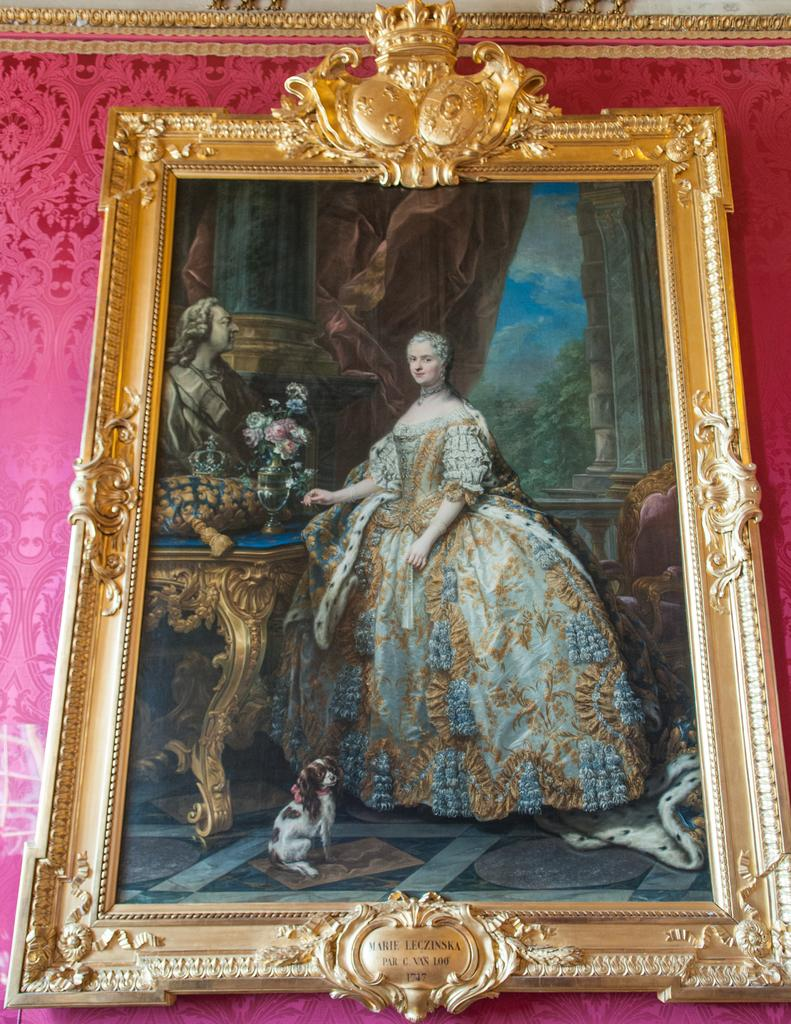What is the color of the surface in the image? The surface in the image is pink. What type of object is present in the image that is used for displaying photos? There is a gold-colored photo frame in the image. What is inside the photo frame? The photo frame contains a photo. Who or what can be seen in the photo? The photo includes a person, a dog, a couch, trees, and the sky. What is the value of the wound on the person's arm in the image? There is no wound present on the person's arm in the image. 